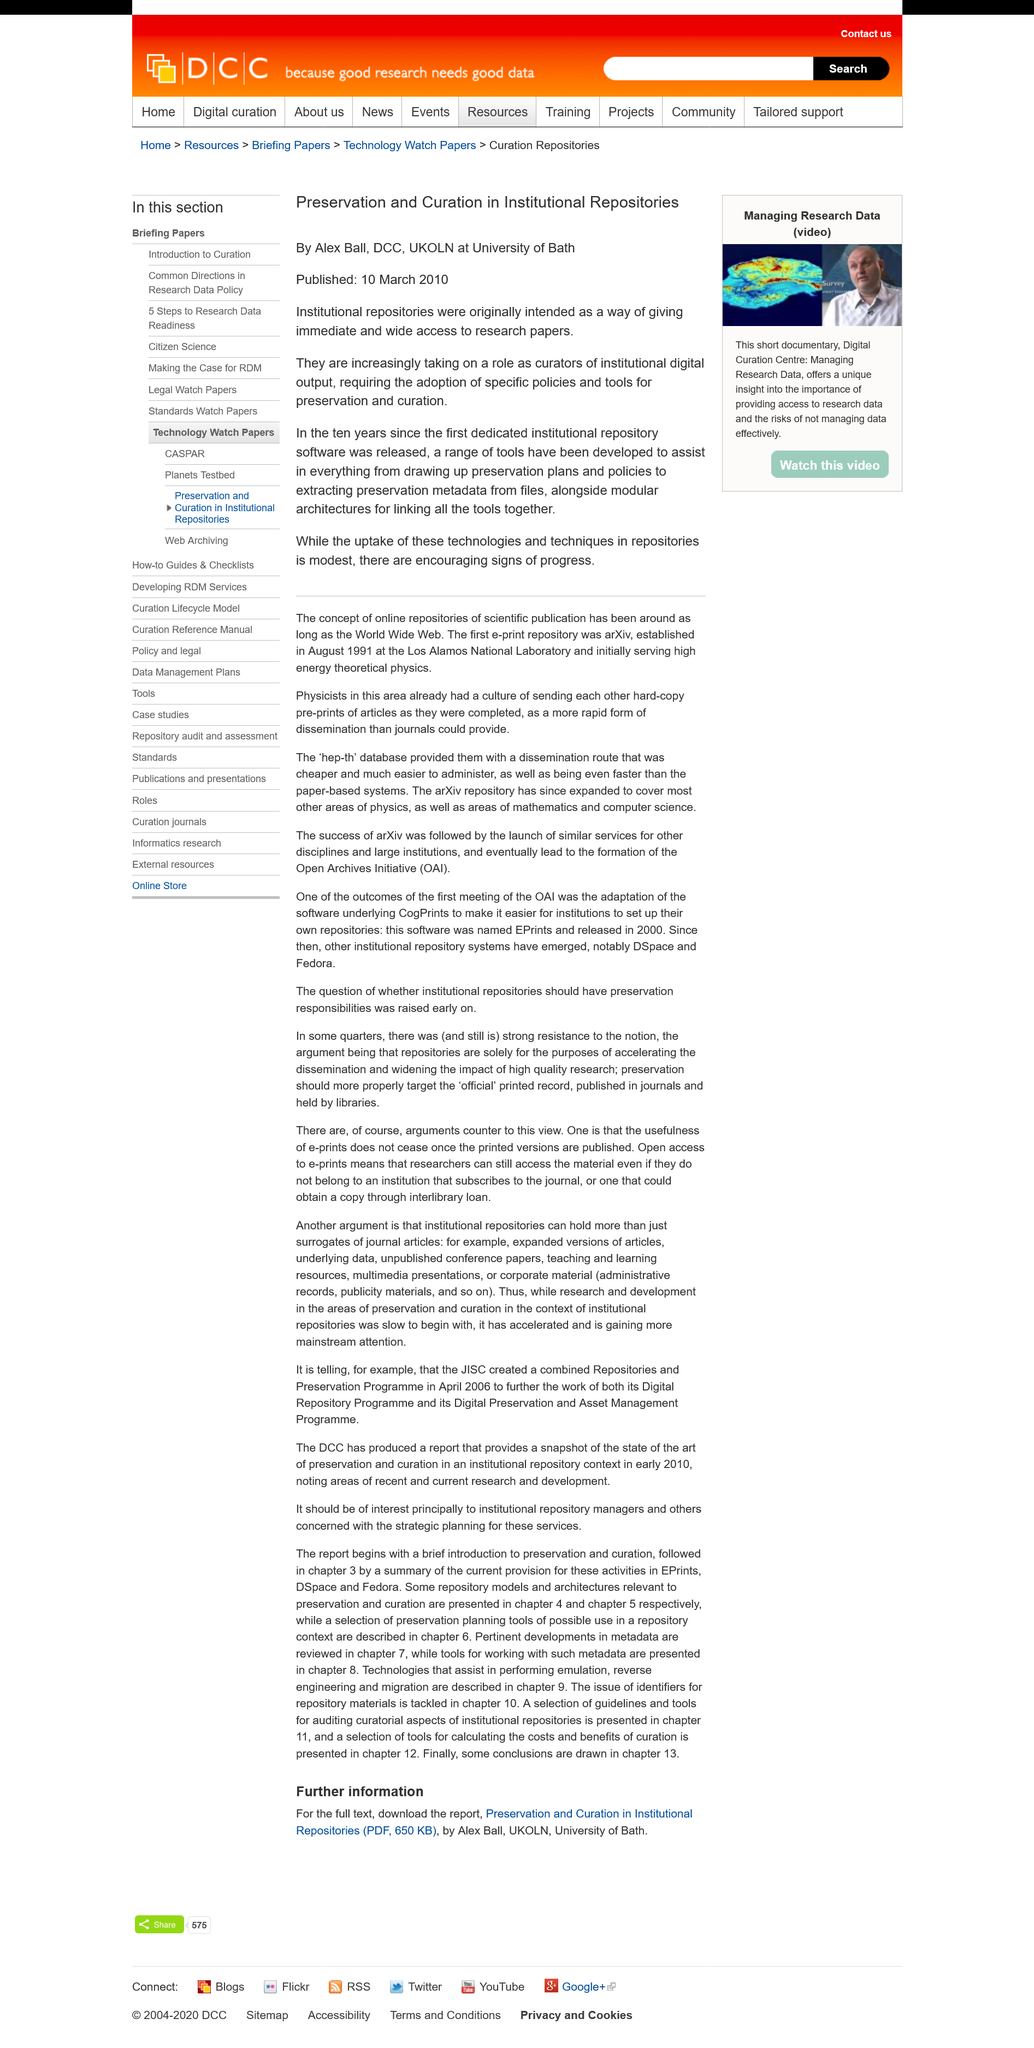Specify some key components in this picture. Alex Ball is a member of the University of Bath. This article, titled "Preservation and Curation in Institutional Repositories," was published on March 10th, 2010. The title of this is "Preservation and Curation in Institutional Repositories... 